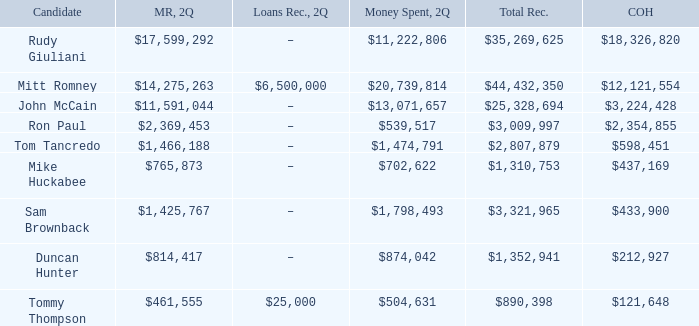Tell me the total receipts for tom tancredo $2,807,879. 